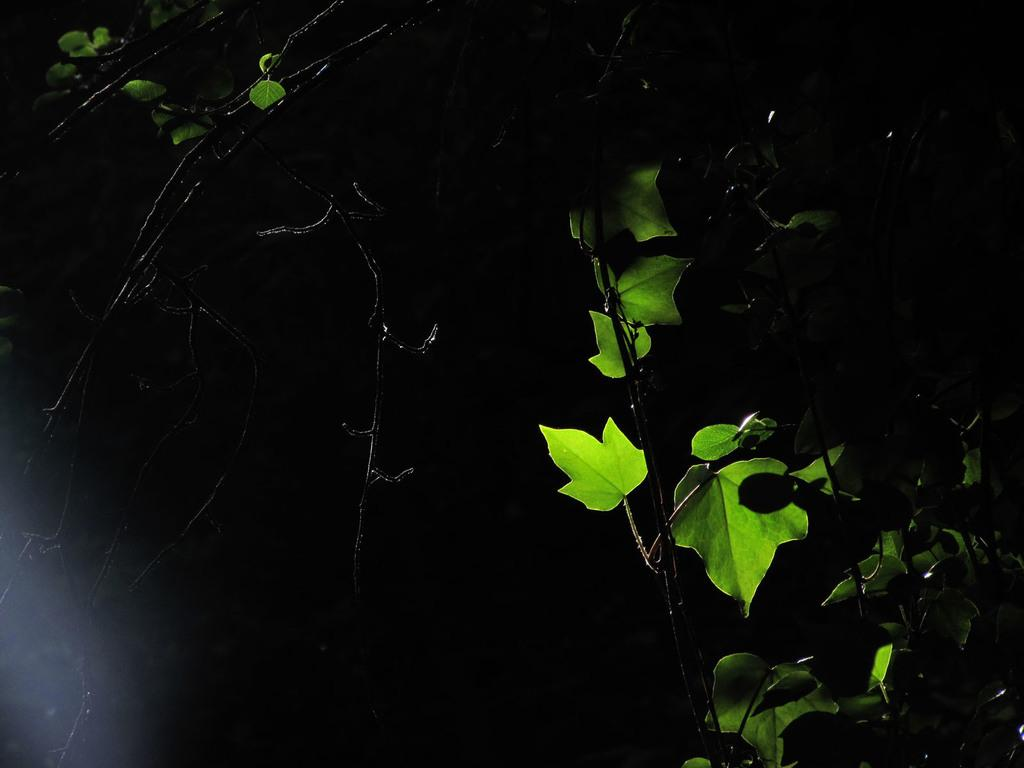What type of living organisms can be seen in the image? There are plants with leaves in the image. What can be observed about the background of the image? The background of the image is dark. How do the plants say good-bye to each other in the image? The plants do not say good-bye to each other in the image, as they are not capable of communicating in that manner. 